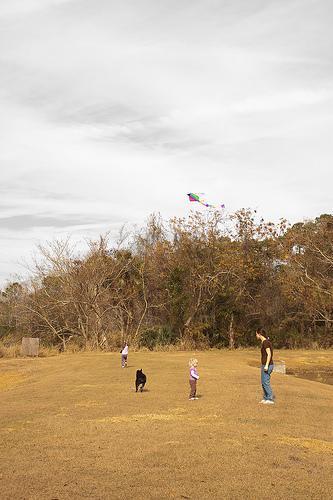How many dogs?
Give a very brief answer. 1. 